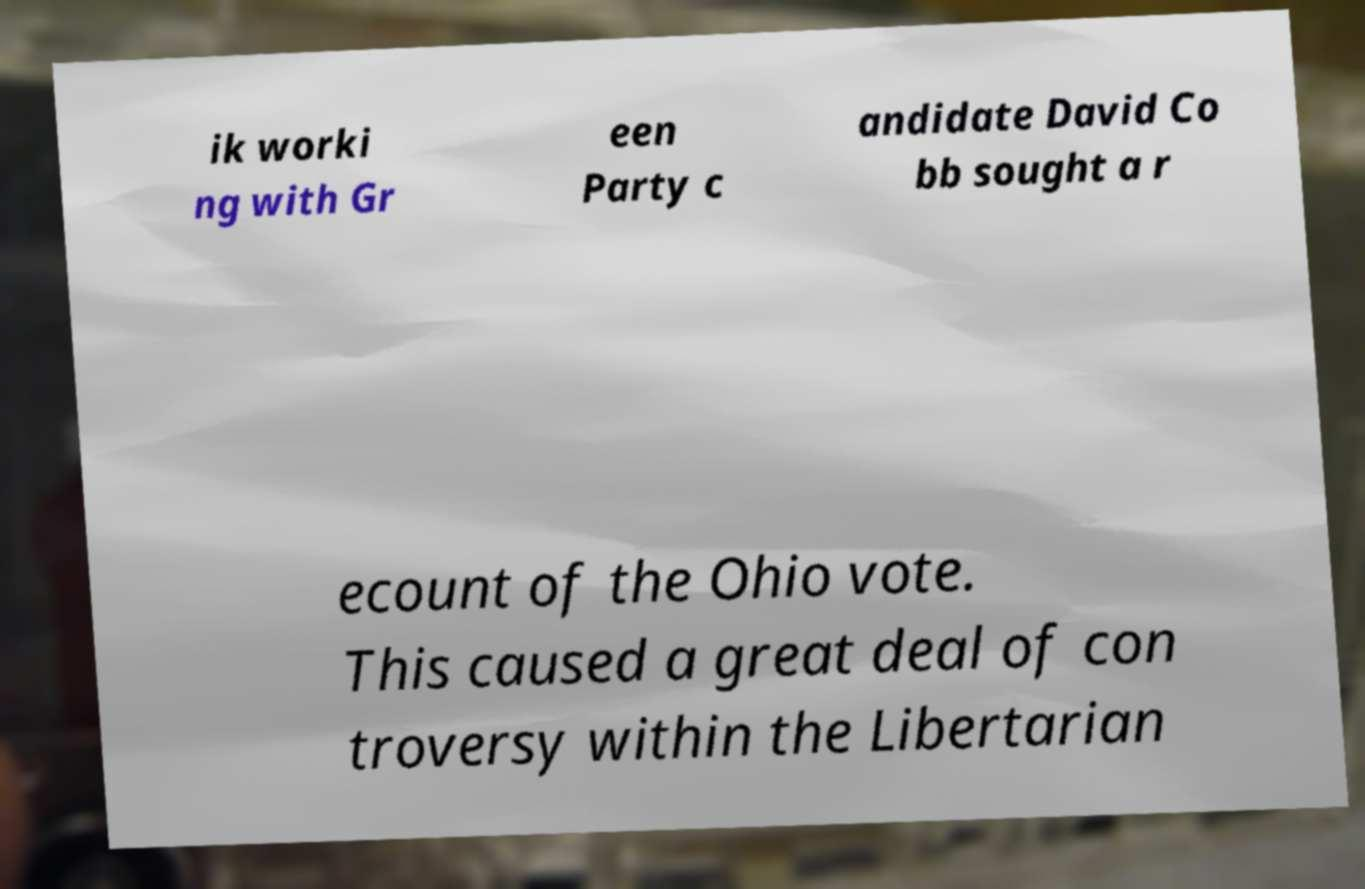Can you accurately transcribe the text from the provided image for me? ik worki ng with Gr een Party c andidate David Co bb sought a r ecount of the Ohio vote. This caused a great deal of con troversy within the Libertarian 